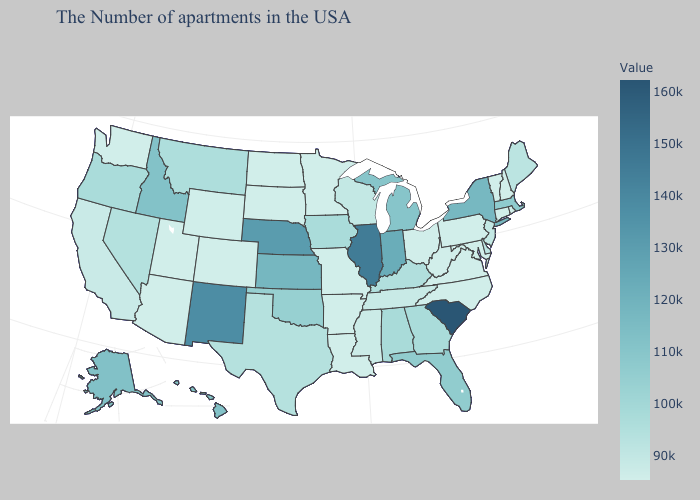Does New Mexico have the highest value in the West?
Short answer required. Yes. Among the states that border New Jersey , does Delaware have the highest value?
Keep it brief. No. Among the states that border Kentucky , which have the lowest value?
Quick response, please. Virginia, West Virginia, Ohio, Missouri. Does Illinois have the highest value in the MidWest?
Quick response, please. Yes. 